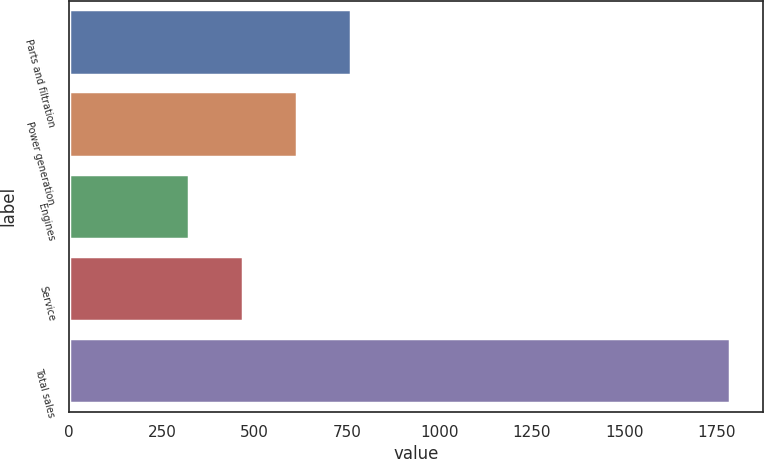Convert chart to OTSL. <chart><loc_0><loc_0><loc_500><loc_500><bar_chart><fcel>Parts and filtration<fcel>Power generation<fcel>Engines<fcel>Service<fcel>Total sales<nl><fcel>762<fcel>616<fcel>324<fcel>470<fcel>1784<nl></chart> 